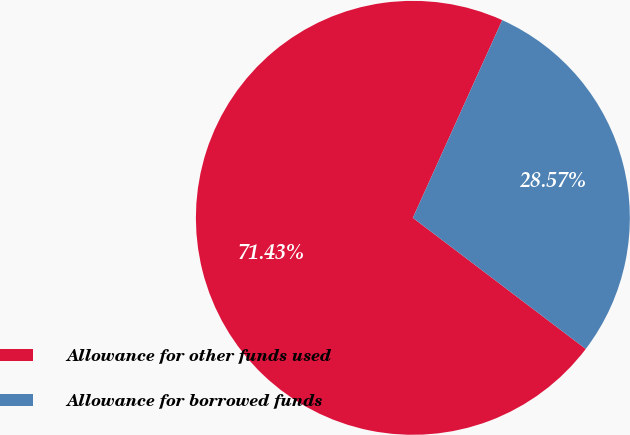Convert chart to OTSL. <chart><loc_0><loc_0><loc_500><loc_500><pie_chart><fcel>Allowance for other funds used<fcel>Allowance for borrowed funds<nl><fcel>71.43%<fcel>28.57%<nl></chart> 